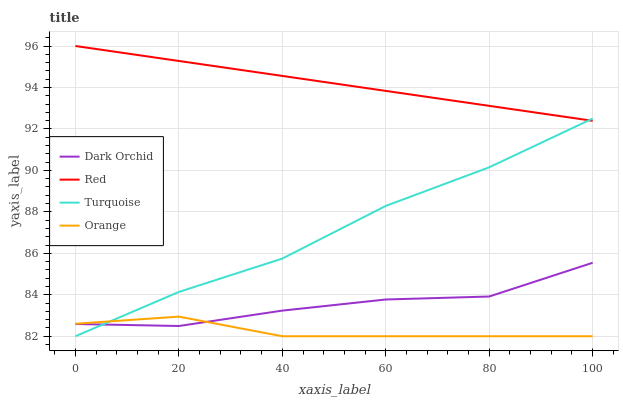Does Orange have the minimum area under the curve?
Answer yes or no. Yes. Does Red have the maximum area under the curve?
Answer yes or no. Yes. Does Turquoise have the minimum area under the curve?
Answer yes or no. No. Does Turquoise have the maximum area under the curve?
Answer yes or no. No. Is Red the smoothest?
Answer yes or no. Yes. Is Dark Orchid the roughest?
Answer yes or no. Yes. Is Turquoise the smoothest?
Answer yes or no. No. Is Turquoise the roughest?
Answer yes or no. No. Does Orange have the lowest value?
Answer yes or no. Yes. Does Red have the lowest value?
Answer yes or no. No. Does Red have the highest value?
Answer yes or no. Yes. Does Turquoise have the highest value?
Answer yes or no. No. Is Orange less than Red?
Answer yes or no. Yes. Is Red greater than Dark Orchid?
Answer yes or no. Yes. Does Orange intersect Dark Orchid?
Answer yes or no. Yes. Is Orange less than Dark Orchid?
Answer yes or no. No. Is Orange greater than Dark Orchid?
Answer yes or no. No. Does Orange intersect Red?
Answer yes or no. No. 